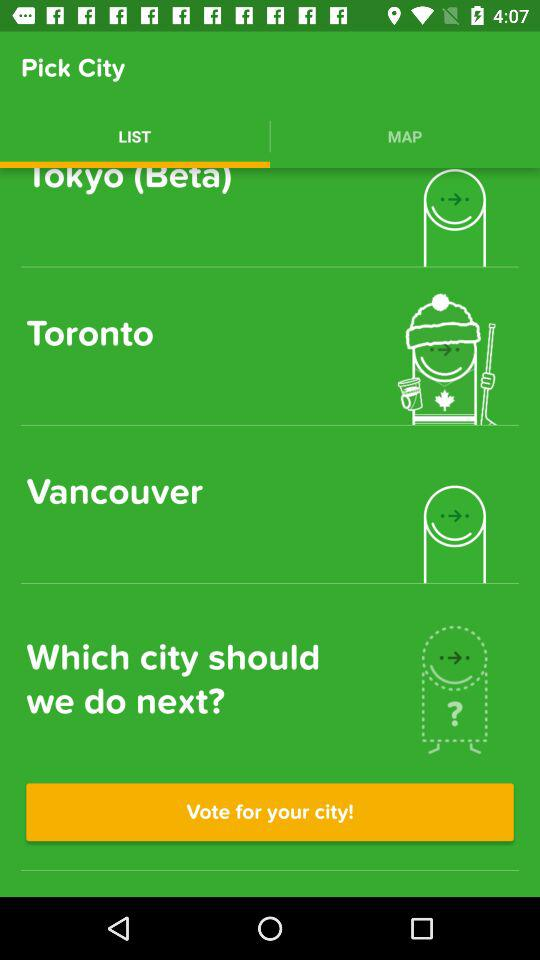Which tab is selected? The selected tab is "LIST". 